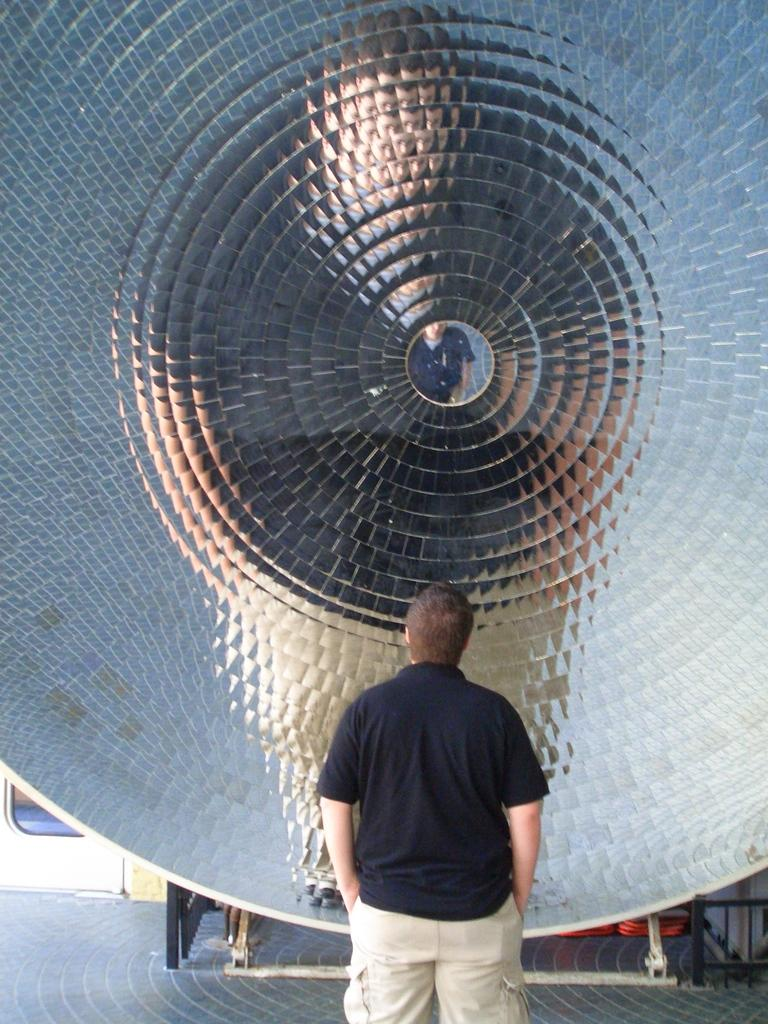What is the main subject of the image? There is a person in the image. What is the person doing in the image? The person is standing on the floor. What can be seen in front of the person? There is a metal object in front of the person. Reasoning: Let'ing: Let's think step by step in order to produce the conversation. We start by identifying the main subject of the image, which is the person. Then, we describe the person's action, which is standing on the floor. Finally, we mention the metal object that is in front of the person. Each question is designed to elicit a specific detail about the image that is known from the provided facts. Absurd Question/Answer: What type of credit card is the person holding in the image? There is no credit card visible in the image; the person is standing in front of a metal object. How many mice can be seen running around the person's feet in the image? There are no mice present in the image; the person is standing in front of a metal object. How many mice can be seen running around the person's feet in the image? There are no mice present in the image; the person is standing in front of a metal object. 